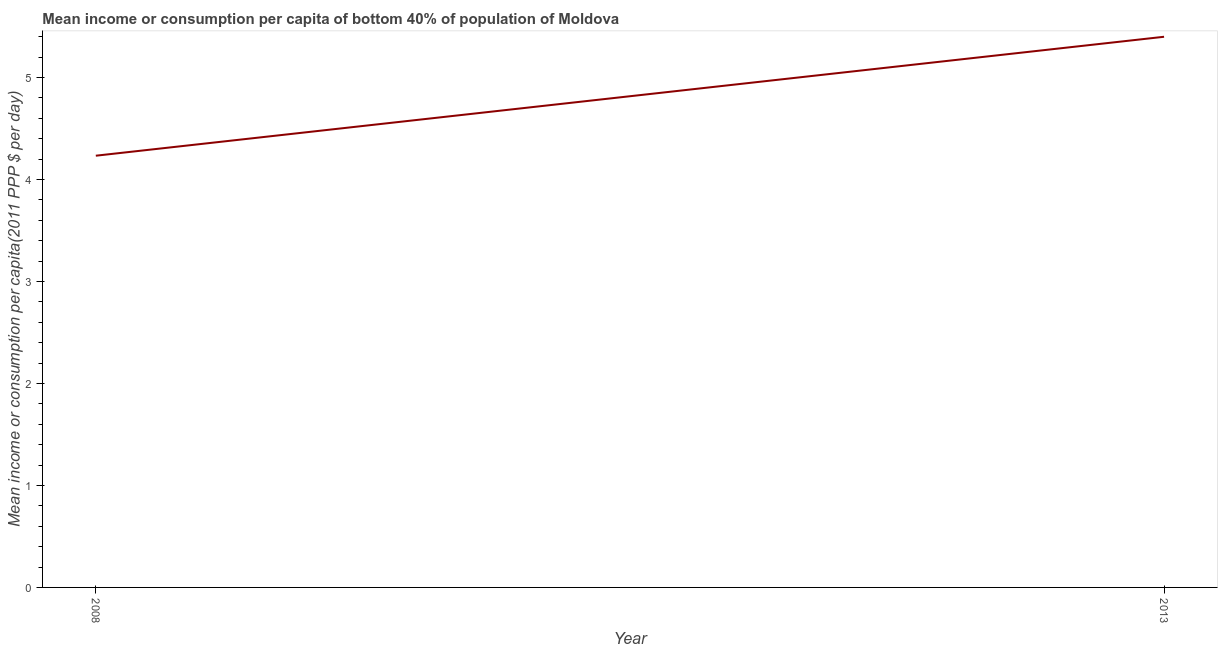What is the mean income or consumption in 2013?
Give a very brief answer. 5.4. Across all years, what is the maximum mean income or consumption?
Provide a short and direct response. 5.4. Across all years, what is the minimum mean income or consumption?
Give a very brief answer. 4.23. What is the sum of the mean income or consumption?
Ensure brevity in your answer.  9.63. What is the difference between the mean income or consumption in 2008 and 2013?
Provide a short and direct response. -1.17. What is the average mean income or consumption per year?
Offer a very short reply. 4.82. What is the median mean income or consumption?
Provide a succinct answer. 4.82. In how many years, is the mean income or consumption greater than 3.8 $?
Offer a very short reply. 2. What is the ratio of the mean income or consumption in 2008 to that in 2013?
Offer a very short reply. 0.78. Is the mean income or consumption in 2008 less than that in 2013?
Give a very brief answer. Yes. In how many years, is the mean income or consumption greater than the average mean income or consumption taken over all years?
Your answer should be compact. 1. How many years are there in the graph?
Provide a short and direct response. 2. What is the difference between two consecutive major ticks on the Y-axis?
Provide a succinct answer. 1. Does the graph contain any zero values?
Offer a very short reply. No. Does the graph contain grids?
Ensure brevity in your answer.  No. What is the title of the graph?
Offer a very short reply. Mean income or consumption per capita of bottom 40% of population of Moldova. What is the label or title of the Y-axis?
Give a very brief answer. Mean income or consumption per capita(2011 PPP $ per day). What is the Mean income or consumption per capita(2011 PPP $ per day) in 2008?
Keep it short and to the point. 4.23. What is the Mean income or consumption per capita(2011 PPP $ per day) of 2013?
Offer a terse response. 5.4. What is the difference between the Mean income or consumption per capita(2011 PPP $ per day) in 2008 and 2013?
Offer a very short reply. -1.17. What is the ratio of the Mean income or consumption per capita(2011 PPP $ per day) in 2008 to that in 2013?
Give a very brief answer. 0.78. 